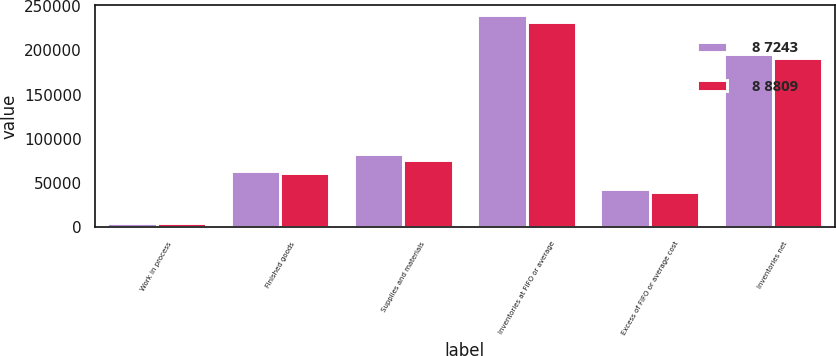Convert chart to OTSL. <chart><loc_0><loc_0><loc_500><loc_500><stacked_bar_chart><ecel><fcel>Work in process<fcel>Finished goods<fcel>Supplies and materials<fcel>Inventories at FIFO or average<fcel>Excess of FIFO or average cost<fcel>Inventories net<nl><fcel>8 7243<fcel>5021<fcel>63633<fcel>83431<fcel>239328<fcel>43382<fcel>195946<nl><fcel>8 8809<fcel>5119<fcel>61994<fcel>76197<fcel>232119<fcel>40291<fcel>191828<nl></chart> 